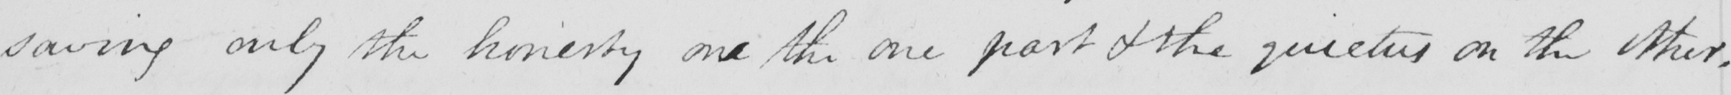Can you read and transcribe this handwriting? saving only the honesty one the one part & the quietus on the other . 